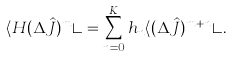<formula> <loc_0><loc_0><loc_500><loc_500>\langle H ( \Delta \hat { J } ) ^ { m } \rangle = \sum _ { n = 0 } ^ { K } h _ { n } \langle ( \Delta \hat { J } ) ^ { m + n } \rangle .</formula> 